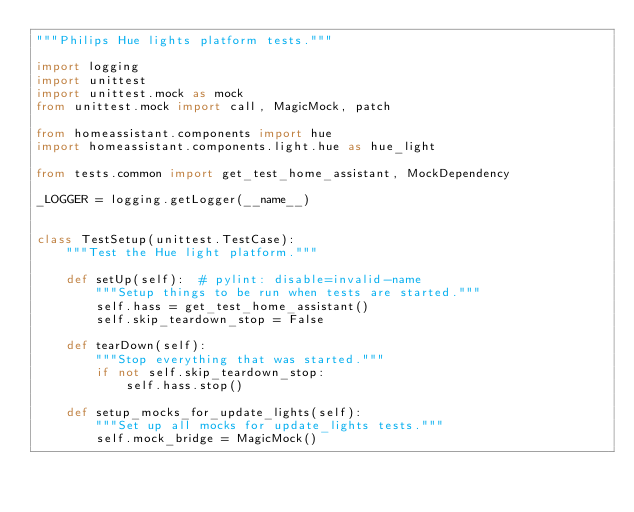<code> <loc_0><loc_0><loc_500><loc_500><_Python_>"""Philips Hue lights platform tests."""

import logging
import unittest
import unittest.mock as mock
from unittest.mock import call, MagicMock, patch

from homeassistant.components import hue
import homeassistant.components.light.hue as hue_light

from tests.common import get_test_home_assistant, MockDependency

_LOGGER = logging.getLogger(__name__)


class TestSetup(unittest.TestCase):
    """Test the Hue light platform."""

    def setUp(self):  # pylint: disable=invalid-name
        """Setup things to be run when tests are started."""
        self.hass = get_test_home_assistant()
        self.skip_teardown_stop = False

    def tearDown(self):
        """Stop everything that was started."""
        if not self.skip_teardown_stop:
            self.hass.stop()

    def setup_mocks_for_update_lights(self):
        """Set up all mocks for update_lights tests."""
        self.mock_bridge = MagicMock()</code> 